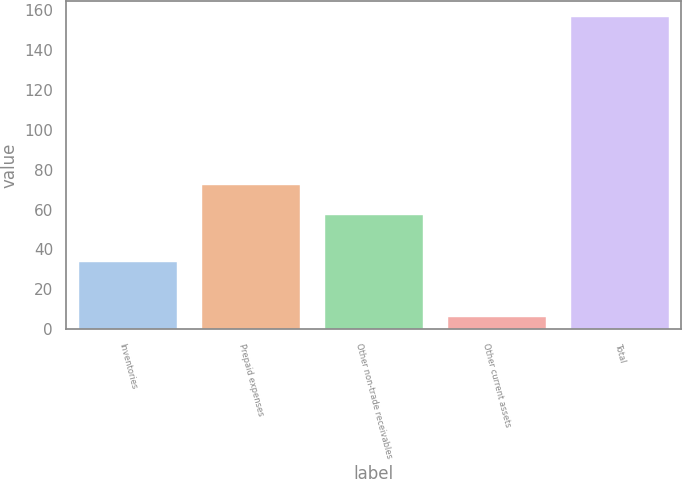Convert chart. <chart><loc_0><loc_0><loc_500><loc_500><bar_chart><fcel>Inventories<fcel>Prepaid expenses<fcel>Other non-trade receivables<fcel>Other current assets<fcel>Total<nl><fcel>33.7<fcel>72.11<fcel>57.1<fcel>6.4<fcel>156.5<nl></chart> 